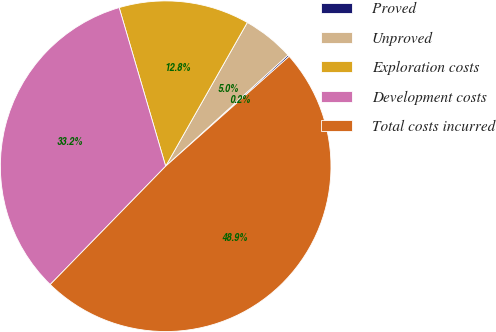<chart> <loc_0><loc_0><loc_500><loc_500><pie_chart><fcel>Proved<fcel>Unproved<fcel>Exploration costs<fcel>Development costs<fcel>Total costs incurred<nl><fcel>0.17%<fcel>5.04%<fcel>12.76%<fcel>33.16%<fcel>48.88%<nl></chart> 